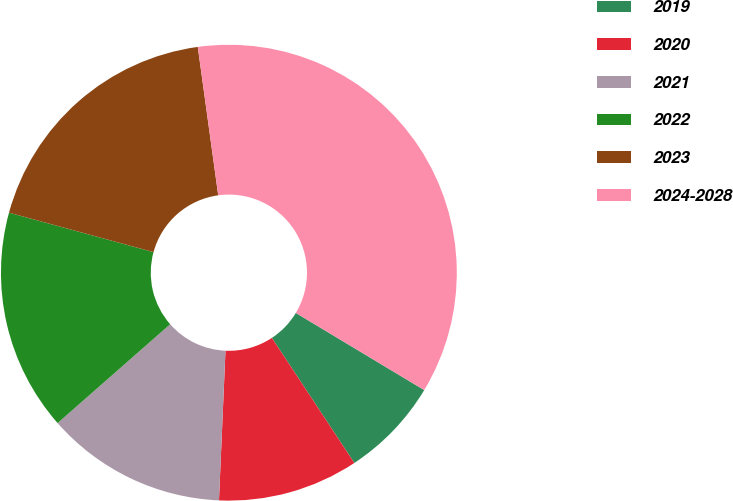Convert chart to OTSL. <chart><loc_0><loc_0><loc_500><loc_500><pie_chart><fcel>2019<fcel>2020<fcel>2021<fcel>2022<fcel>2023<fcel>2024-2028<nl><fcel>7.11%<fcel>9.97%<fcel>12.84%<fcel>15.71%<fcel>18.58%<fcel>35.79%<nl></chart> 